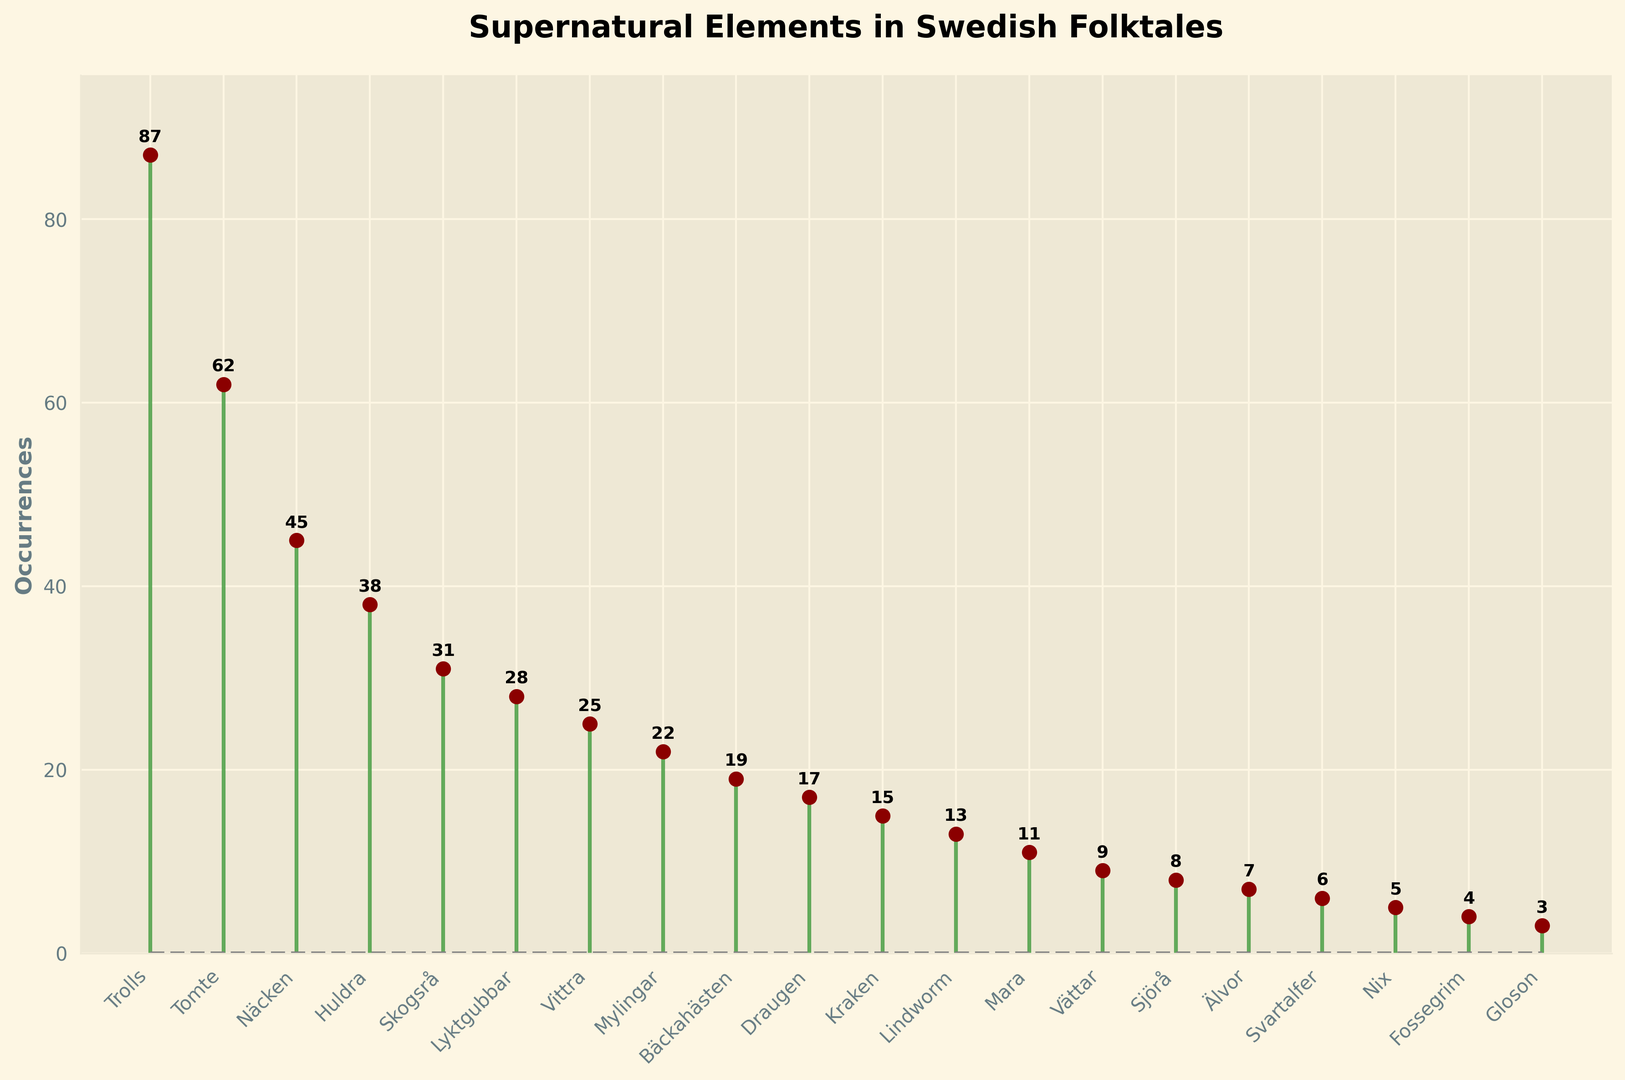what is the most frequent supernatural element mentioned in Swedish folktales? The figure shows "Trolls" with the highest occurrence. To identify this, look for the tallest marker with the highest value.
Answer: Trolls What is the difference in occurrences between Tomte and Näcken? Find and subtract the number of occurrences for Näcken from that of Tomte. Tomte has 62 and Näcken has 45. 62 - 45 = 17
Answer: 17 How many supernatural elements have fewer than 10 occurrences? Count the number of elements where the marker's height is less than 10. This includes Vättar, Sjörå, Älvor, Svartalfer, Nix, Fossegrim, and Gloson.
Answer: 7 Which two supernatural elements have occurrences closest to 60? Identify the markers nearest to the value of 60. Tomte (62) and Näcken (45) are the closest, with Tomte being just above 60.
Answer: Tomte and Näcken What is the total number of occurrences for all elements listed in the figure? Sum the occurrences of all elements: 87+62+45+38+31+28+25+22+19+17+15+13+11+9+8+7+6+5+4+3 = 354
Answer: 354 Which supernatural element has exactly 25 occurrences, and which one has the least? Based on the figure, Vittra has exactly 25 occurrences. The least occurrences are by Gloson, which has 3.
Answer: Vittra; Gloson How many more occurrences are there for Huldra compared to Skogsrå? Subtract the number of occurrences for Skogsrå from Huldra. Huldra has 38 occurrences, and Skogsrå has 31. 38 - 31 = 7
Answer: 7 Of the supernatural elements listed with occurrence below 20, which one has the highest occurrences? Look for the highest marker among those below 20 occurrences. Bäckahästen has 19 occurrences, which is the highest among elements below 20.
Answer: Bäckahästen What is the average occurrence for the top five most frequent supernatural elements? Calculate the sum of occurrences for the top five frequent types and divide by 5. (87 + 62 + 45 + 38 + 31) / 5 = 263 / 5 = 52.6
Answer: 52.6 